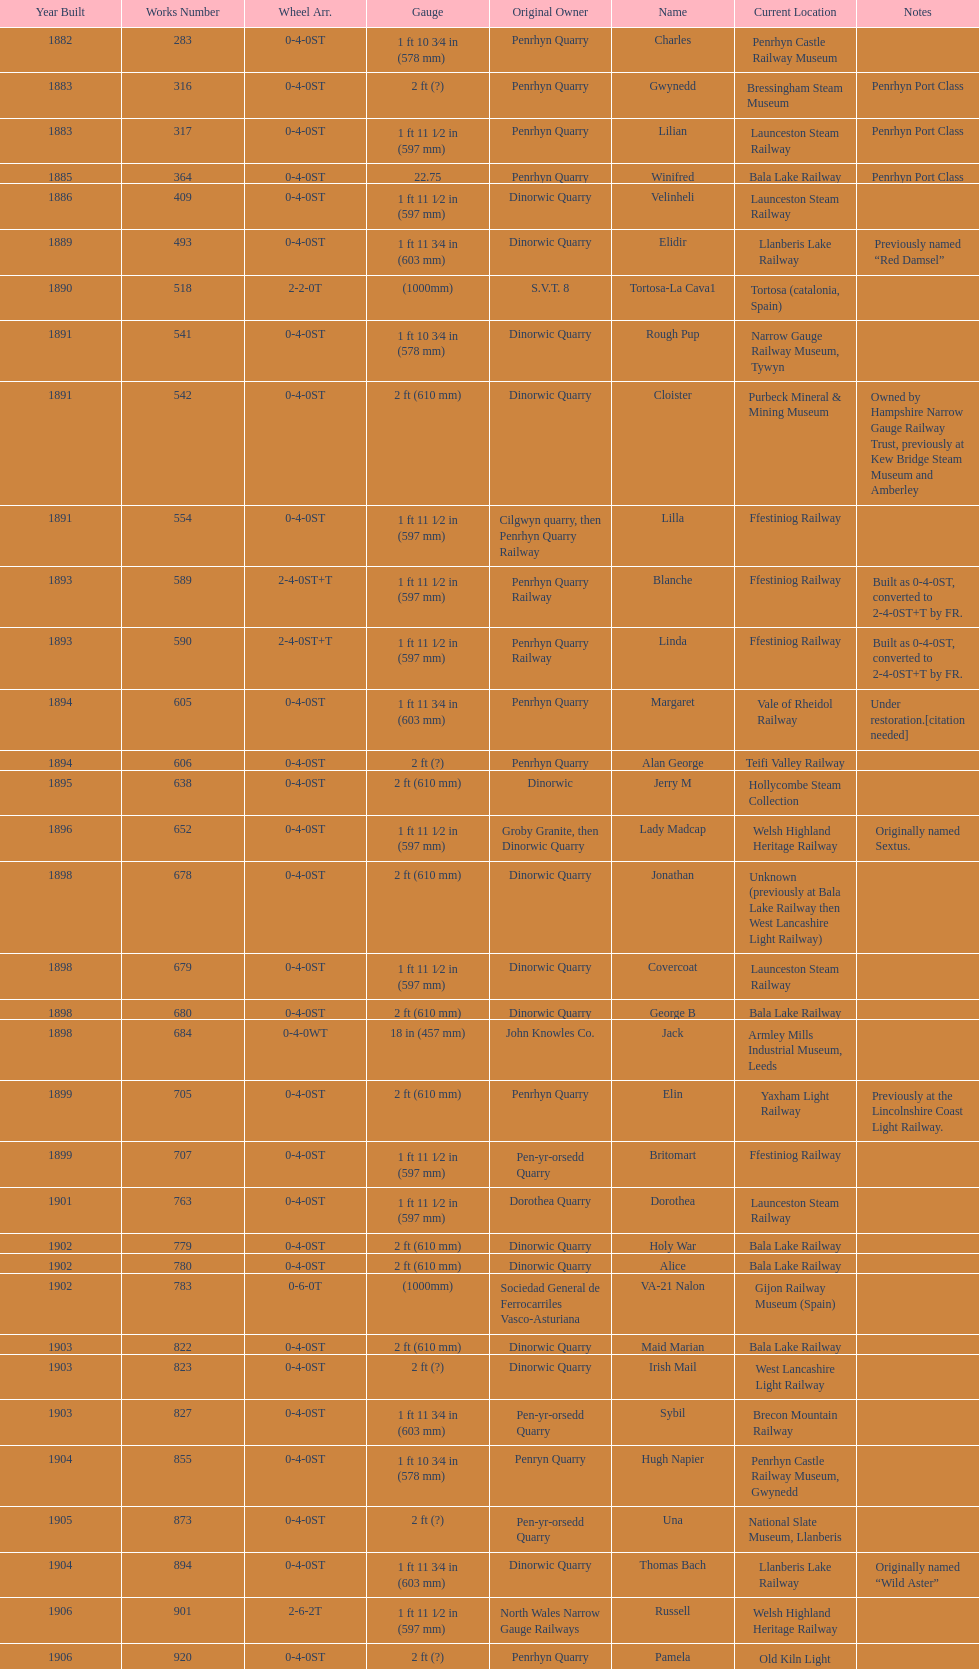Could you parse the entire table? {'header': ['Year Built', 'Works Number', 'Wheel Arr.', 'Gauge', 'Original Owner', 'Name', 'Current Location', 'Notes'], 'rows': [['1882', '283', '0-4-0ST', '1\xa0ft 10\xa03⁄4\xa0in (578\xa0mm)', 'Penrhyn Quarry', 'Charles', 'Penrhyn Castle Railway Museum', ''], ['1883', '316', '0-4-0ST', '2\xa0ft (?)', 'Penrhyn Quarry', 'Gwynedd', 'Bressingham Steam Museum', 'Penrhyn Port Class'], ['1883', '317', '0-4-0ST', '1\xa0ft 11\xa01⁄2\xa0in (597\xa0mm)', 'Penrhyn Quarry', 'Lilian', 'Launceston Steam Railway', 'Penrhyn Port Class'], ['1885', '364', '0-4-0ST', '22.75', 'Penrhyn Quarry', 'Winifred', 'Bala Lake Railway', 'Penrhyn Port Class'], ['1886', '409', '0-4-0ST', '1\xa0ft 11\xa01⁄2\xa0in (597\xa0mm)', 'Dinorwic Quarry', 'Velinheli', 'Launceston Steam Railway', ''], ['1889', '493', '0-4-0ST', '1\xa0ft 11\xa03⁄4\xa0in (603\xa0mm)', 'Dinorwic Quarry', 'Elidir', 'Llanberis Lake Railway', 'Previously named “Red Damsel”'], ['1890', '518', '2-2-0T', '(1000mm)', 'S.V.T. 8', 'Tortosa-La Cava1', 'Tortosa (catalonia, Spain)', ''], ['1891', '541', '0-4-0ST', '1\xa0ft 10\xa03⁄4\xa0in (578\xa0mm)', 'Dinorwic Quarry', 'Rough Pup', 'Narrow Gauge Railway Museum, Tywyn', ''], ['1891', '542', '0-4-0ST', '2\xa0ft (610\xa0mm)', 'Dinorwic Quarry', 'Cloister', 'Purbeck Mineral & Mining Museum', 'Owned by Hampshire Narrow Gauge Railway Trust, previously at Kew Bridge Steam Museum and Amberley'], ['1891', '554', '0-4-0ST', '1\xa0ft 11\xa01⁄2\xa0in (597\xa0mm)', 'Cilgwyn quarry, then Penrhyn Quarry Railway', 'Lilla', 'Ffestiniog Railway', ''], ['1893', '589', '2-4-0ST+T', '1\xa0ft 11\xa01⁄2\xa0in (597\xa0mm)', 'Penrhyn Quarry Railway', 'Blanche', 'Ffestiniog Railway', 'Built as 0-4-0ST, converted to 2-4-0ST+T by FR.'], ['1893', '590', '2-4-0ST+T', '1\xa0ft 11\xa01⁄2\xa0in (597\xa0mm)', 'Penrhyn Quarry Railway', 'Linda', 'Ffestiniog Railway', 'Built as 0-4-0ST, converted to 2-4-0ST+T by FR.'], ['1894', '605', '0-4-0ST', '1\xa0ft 11\xa03⁄4\xa0in (603\xa0mm)', 'Penrhyn Quarry', 'Margaret', 'Vale of Rheidol Railway', 'Under restoration.[citation needed]'], ['1894', '606', '0-4-0ST', '2\xa0ft (?)', 'Penrhyn Quarry', 'Alan George', 'Teifi Valley Railway', ''], ['1895', '638', '0-4-0ST', '2\xa0ft (610\xa0mm)', 'Dinorwic', 'Jerry M', 'Hollycombe Steam Collection', ''], ['1896', '652', '0-4-0ST', '1\xa0ft 11\xa01⁄2\xa0in (597\xa0mm)', 'Groby Granite, then Dinorwic Quarry', 'Lady Madcap', 'Welsh Highland Heritage Railway', 'Originally named Sextus.'], ['1898', '678', '0-4-0ST', '2\xa0ft (610\xa0mm)', 'Dinorwic Quarry', 'Jonathan', 'Unknown (previously at Bala Lake Railway then West Lancashire Light Railway)', ''], ['1898', '679', '0-4-0ST', '1\xa0ft 11\xa01⁄2\xa0in (597\xa0mm)', 'Dinorwic Quarry', 'Covercoat', 'Launceston Steam Railway', ''], ['1898', '680', '0-4-0ST', '2\xa0ft (610\xa0mm)', 'Dinorwic Quarry', 'George B', 'Bala Lake Railway', ''], ['1898', '684', '0-4-0WT', '18\xa0in (457\xa0mm)', 'John Knowles Co.', 'Jack', 'Armley Mills Industrial Museum, Leeds', ''], ['1899', '705', '0-4-0ST', '2\xa0ft (610\xa0mm)', 'Penrhyn Quarry', 'Elin', 'Yaxham Light Railway', 'Previously at the Lincolnshire Coast Light Railway.'], ['1899', '707', '0-4-0ST', '1\xa0ft 11\xa01⁄2\xa0in (597\xa0mm)', 'Pen-yr-orsedd Quarry', 'Britomart', 'Ffestiniog Railway', ''], ['1901', '763', '0-4-0ST', '1\xa0ft 11\xa01⁄2\xa0in (597\xa0mm)', 'Dorothea Quarry', 'Dorothea', 'Launceston Steam Railway', ''], ['1902', '779', '0-4-0ST', '2\xa0ft (610\xa0mm)', 'Dinorwic Quarry', 'Holy War', 'Bala Lake Railway', ''], ['1902', '780', '0-4-0ST', '2\xa0ft (610\xa0mm)', 'Dinorwic Quarry', 'Alice', 'Bala Lake Railway', ''], ['1902', '783', '0-6-0T', '(1000mm)', 'Sociedad General de Ferrocarriles Vasco-Asturiana', 'VA-21 Nalon', 'Gijon Railway Museum (Spain)', ''], ['1903', '822', '0-4-0ST', '2\xa0ft (610\xa0mm)', 'Dinorwic Quarry', 'Maid Marian', 'Bala Lake Railway', ''], ['1903', '823', '0-4-0ST', '2\xa0ft (?)', 'Dinorwic Quarry', 'Irish Mail', 'West Lancashire Light Railway', ''], ['1903', '827', '0-4-0ST', '1\xa0ft 11\xa03⁄4\xa0in (603\xa0mm)', 'Pen-yr-orsedd Quarry', 'Sybil', 'Brecon Mountain Railway', ''], ['1904', '855', '0-4-0ST', '1\xa0ft 10\xa03⁄4\xa0in (578\xa0mm)', 'Penryn Quarry', 'Hugh Napier', 'Penrhyn Castle Railway Museum, Gwynedd', ''], ['1905', '873', '0-4-0ST', '2\xa0ft (?)', 'Pen-yr-orsedd Quarry', 'Una', 'National Slate Museum, Llanberis', ''], ['1904', '894', '0-4-0ST', '1\xa0ft 11\xa03⁄4\xa0in (603\xa0mm)', 'Dinorwic Quarry', 'Thomas Bach', 'Llanberis Lake Railway', 'Originally named “Wild Aster”'], ['1906', '901', '2-6-2T', '1\xa0ft 11\xa01⁄2\xa0in (597\xa0mm)', 'North Wales Narrow Gauge Railways', 'Russell', 'Welsh Highland Heritage Railway', ''], ['1906', '920', '0-4-0ST', '2\xa0ft (?)', 'Penrhyn Quarry', 'Pamela', 'Old Kiln Light Railway', ''], ['1909', '994', '0-4-0ST', '2\xa0ft (?)', 'Penrhyn Quarry', 'Bill Harvey', 'Bressingham Steam Museum', 'previously George Sholto'], ['1918', '1312', '4-6-0T', '1\xa0ft\xa011\xa01⁄2\xa0in (597\xa0mm)', 'British War Department\\nEFOP #203', '---', 'Pampas Safari, Gravataí, RS, Brazil', '[citation needed]'], ['1918\\nor\\n1921?', '1313', '0-6-2T', '3\xa0ft\xa03\xa03⁄8\xa0in (1,000\xa0mm)', 'British War Department\\nUsina Leão Utinga #1\\nUsina Laginha #1', '---', 'Usina Laginha, União dos Palmares, AL, Brazil', '[citation needed]'], ['1920', '1404', '0-4-0WT', '18\xa0in (457\xa0mm)', 'John Knowles Co.', 'Gwen', 'Richard Farmer current owner, Northridge, California, USA', ''], ['1922', '1429', '0-4-0ST', '2\xa0ft (610\xa0mm)', 'Dinorwic', 'Lady Joan', 'Bredgar and Wormshill Light Railway', ''], ['1922', '1430', '0-4-0ST', '1\xa0ft 11\xa03⁄4\xa0in (603\xa0mm)', 'Dinorwic Quarry', 'Dolbadarn', 'Llanberis Lake Railway', ''], ['1937', '1859', '0-4-2T', '2\xa0ft (?)', 'Umtwalumi Valley Estate, Natal', '16 Carlisle', 'South Tynedale Railway', ''], ['1940', '2075', '0-4-2T', '2\xa0ft (?)', 'Chaka’s Kraal Sugar Estates, Natal', 'Chaka’s Kraal No. 6', 'North Gloucestershire Railway', ''], ['1954', '3815', '2-6-2T', '2\xa0ft 6\xa0in (762\xa0mm)', 'Sierra Leone Government Railway', '14', 'Welshpool and Llanfair Light Railway', ''], ['1971', '3902', '0-4-2ST', '2\xa0ft (610\xa0mm)', 'Trangkil Sugar Mill, Indonesia', 'Trangkil No.4', 'Statfold Barn Railway', 'Converted from 750\xa0mm (2\xa0ft\xa05\xa01⁄2\xa0in) gauge. Last steam locomotive to be built by Hunslet, and the last industrial steam locomotive built in Britain.']]} After 1940, how many steam engines were constructed? 2. 